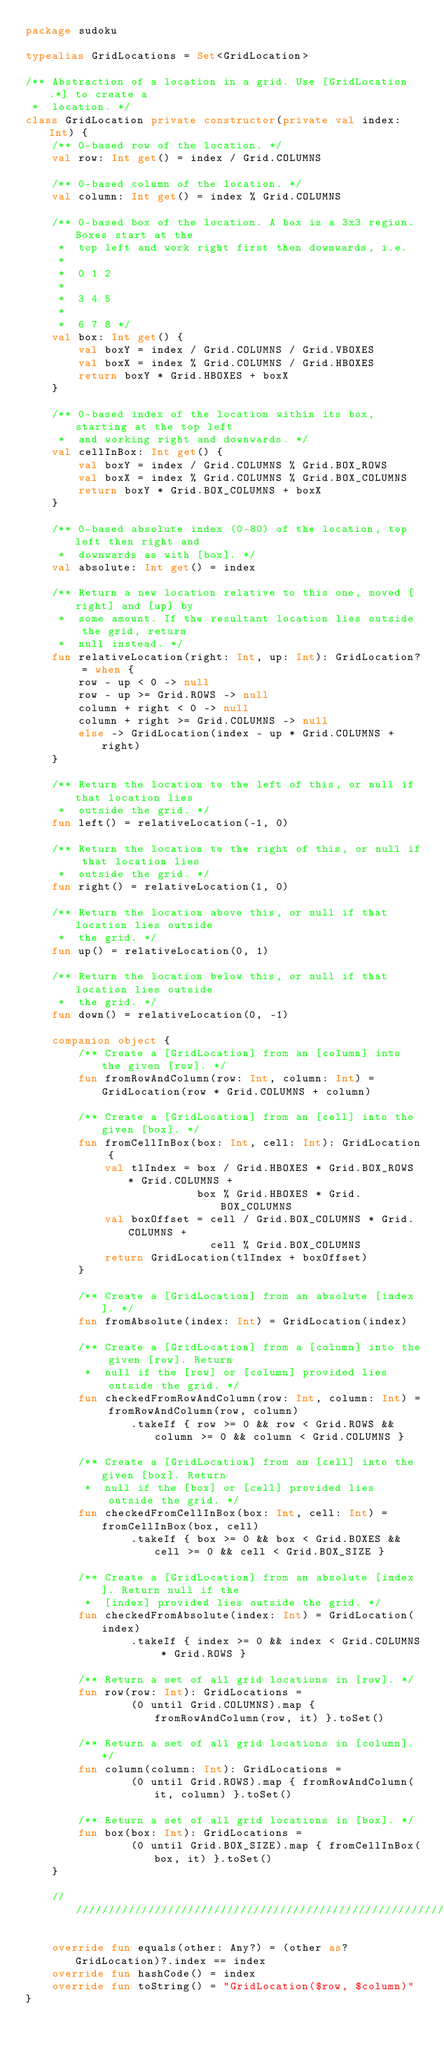Convert code to text. <code><loc_0><loc_0><loc_500><loc_500><_Kotlin_>package sudoku

typealias GridLocations = Set<GridLocation>

/** Abstraction of a location in a grid. Use [GridLocation.*] to create a
 *  location. */
class GridLocation private constructor(private val index: Int) {
    /** 0-based row of the location. */
    val row: Int get() = index / Grid.COLUMNS

    /** 0-based column of the location. */
    val column: Int get() = index % Grid.COLUMNS

    /** 0-based box of the location. A box is a 3x3 region. Boxes start at the
     *  top left and work right first then downwards, i.e.
     *
     *  0 1 2
     *
     *  3 4 5
     *
     *  6 7 8 */
    val box: Int get() {
        val boxY = index / Grid.COLUMNS / Grid.VBOXES
        val boxX = index % Grid.COLUMNS / Grid.HBOXES
        return boxY * Grid.HBOXES + boxX
    }

    /** 0-based index of the location within its box, starting at the top left
     *  and working right and downwards. */
    val cellInBox: Int get() {
        val boxY = index / Grid.COLUMNS % Grid.BOX_ROWS
        val boxX = index % Grid.COLUMNS % Grid.BOX_COLUMNS
        return boxY * Grid.BOX_COLUMNS + boxX
    }

    /** 0-based absolute index (0-80) of the location, top left then right and
     *  downwards as with [box]. */
    val absolute: Int get() = index

    /** Return a new location relative to this one, moved [right] and [up] by
     *  some amount. If the resultant location lies outside the grid, return
     *  null instead. */
    fun relativeLocation(right: Int, up: Int): GridLocation? = when {
        row - up < 0 -> null
        row - up >= Grid.ROWS -> null
        column + right < 0 -> null
        column + right >= Grid.COLUMNS -> null
        else -> GridLocation(index - up * Grid.COLUMNS + right)
    }

    /** Return the location to the left of this, or null if that location lies
     *  outside the grid. */
    fun left() = relativeLocation(-1, 0)

    /** Return the location to the right of this, or null if that location lies
     *  outside the grid. */
    fun right() = relativeLocation(1, 0)

    /** Return the location above this, or null if that location lies outside
     *  the grid. */
    fun up() = relativeLocation(0, 1)

    /** Return the location below this, or null if that location lies outside
     *  the grid. */
    fun down() = relativeLocation(0, -1)

    companion object {
        /** Create a [GridLocation] from an [column] into the given [row]. */
        fun fromRowAndColumn(row: Int, column: Int) = GridLocation(row * Grid.COLUMNS + column)

        /** Create a [GridLocation] from an [cell] into the given [box]. */
        fun fromCellInBox(box: Int, cell: Int): GridLocation {
            val tlIndex = box / Grid.HBOXES * Grid.BOX_ROWS * Grid.COLUMNS +
                          box % Grid.HBOXES * Grid.BOX_COLUMNS
            val boxOffset = cell / Grid.BOX_COLUMNS * Grid.COLUMNS +
                            cell % Grid.BOX_COLUMNS
            return GridLocation(tlIndex + boxOffset)
        }

        /** Create a [GridLocation] from an absolute [index]. */
        fun fromAbsolute(index: Int) = GridLocation(index)

        /** Create a [GridLocation] from a [column] into the given [row]. Return
         *  null if the [row] or [column] provided lies outside the grid. */
        fun checkedFromRowAndColumn(row: Int, column: Int) = fromRowAndColumn(row, column)
                .takeIf { row >= 0 && row < Grid.ROWS && column >= 0 && column < Grid.COLUMNS }

        /** Create a [GridLocation] from an [cell] into the given [box]. Return
         *  null if the [box] or [cell] provided lies outside the grid. */
        fun checkedFromCellInBox(box: Int, cell: Int) = fromCellInBox(box, cell)
                .takeIf { box >= 0 && box < Grid.BOXES && cell >= 0 && cell < Grid.BOX_SIZE }

        /** Create a [GridLocation] from an absolute [index]. Return null if the
         *  [index] provided lies outside the grid. */
        fun checkedFromAbsolute(index: Int) = GridLocation(index)
                .takeIf { index >= 0 && index < Grid.COLUMNS * Grid.ROWS }

        /** Return a set of all grid locations in [row]. */
        fun row(row: Int): GridLocations =
                (0 until Grid.COLUMNS).map { fromRowAndColumn(row, it) }.toSet()

        /** Return a set of all grid locations in [column]. */
        fun column(column: Int): GridLocations =
                (0 until Grid.ROWS).map { fromRowAndColumn(it, column) }.toSet()

        /** Return a set of all grid locations in [box]. */
        fun box(box: Int): GridLocations =
                (0 until Grid.BOX_SIZE).map { fromCellInBox(box, it) }.toSet()
    }

    //////////////////////////////////////////////////////////////////////////////////////

    override fun equals(other: Any?) = (other as? GridLocation)?.index == index
    override fun hashCode() = index
    override fun toString() = "GridLocation($row, $column)"
}
</code> 